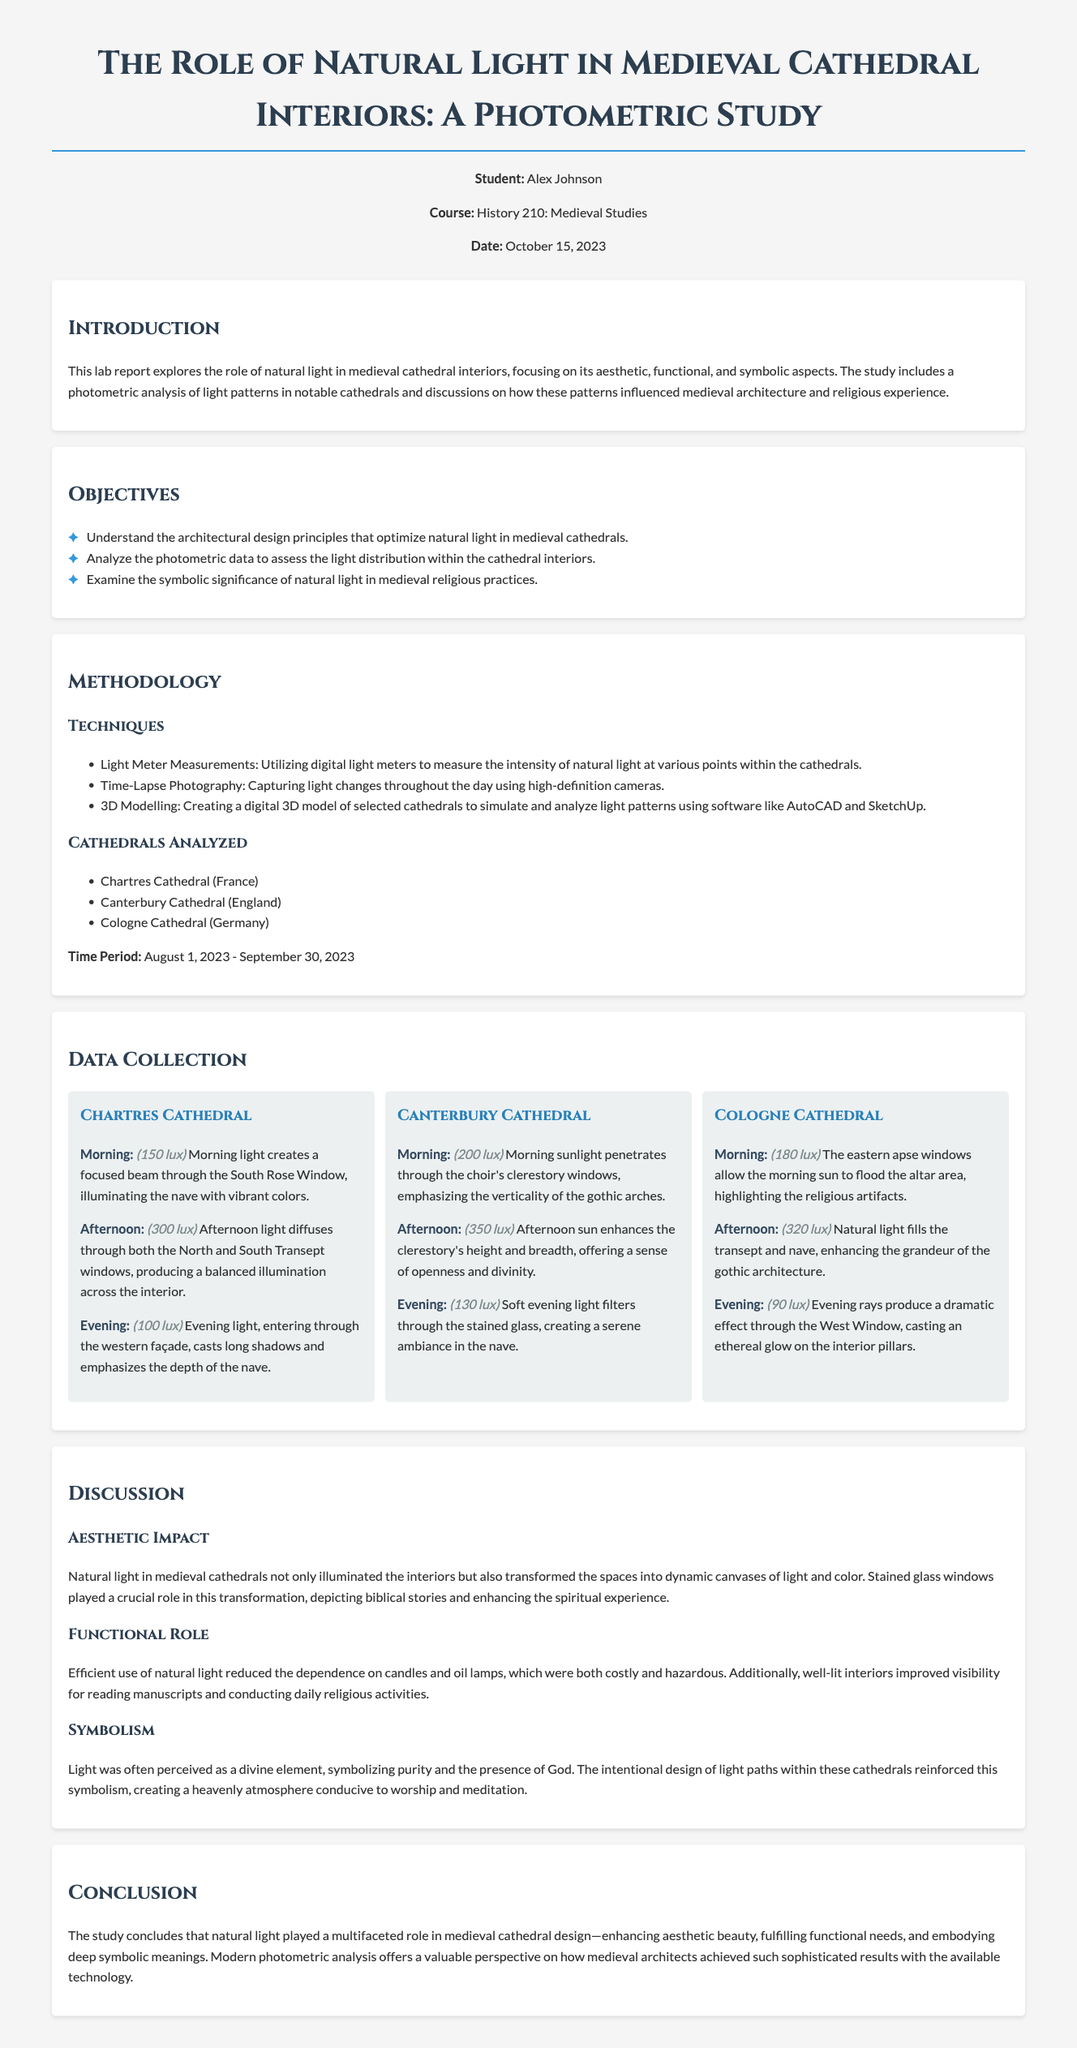what is the title of the lab report? The title describes the focus of the study on natural light in medieval cathedral interiors.
Answer: The Role of Natural Light in Medieval Cathedral Interiors: A Photometric Study who is the student author of the report? This indicates the individual who conducted the study and authored the report.
Answer: Alex Johnson what is the primary method used for measuring light in the cathedrals? The method refers to the technique employed to quantify natural light intensity within the studied cathedrals.
Answer: Light Meter Measurements which cathedrals were analyzed in the study? The question asks for the names of the specific cathedrals included in the photometric analysis.
Answer: Chartres Cathedral, Canterbury Cathedral, Cologne Cathedral what time of day had the highest recorded lux at Canterbury Cathedral? This examines the time period during which the light intensity was measured to be the greatest in that cathedral.
Answer: Afternoon (350 lux) what is one aesthetic impact of natural light mentioned in the document? The question looks for a specific effect or transformation attributed to natural light on cathedral interiors.
Answer: Dynamic canvases of light and color what is the date range of the data collection for the study? The date range signifies the period during which observations and measurements were taken in the cathedrals.
Answer: August 1, 2023 - September 30, 2023 what role does natural light play in reducing costs according to the report? This question seeks to identify the financial implications discussed regarding the use of natural light in relation to artificial lighting sources.
Answer: Reduced dependence on candles and oil lamps in which section would you find the objectives of the report? The objectives outline the goals of the study and are found in a specific part of the lab report.
Answer: Objectives section 